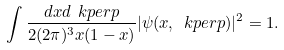Convert formula to latex. <formula><loc_0><loc_0><loc_500><loc_500>\int \frac { d x d \ k p e r p } { 2 ( 2 \pi ) ^ { 3 } x ( 1 - x ) } | \psi ( x , \ k p e r p ) | ^ { 2 } = 1 .</formula> 